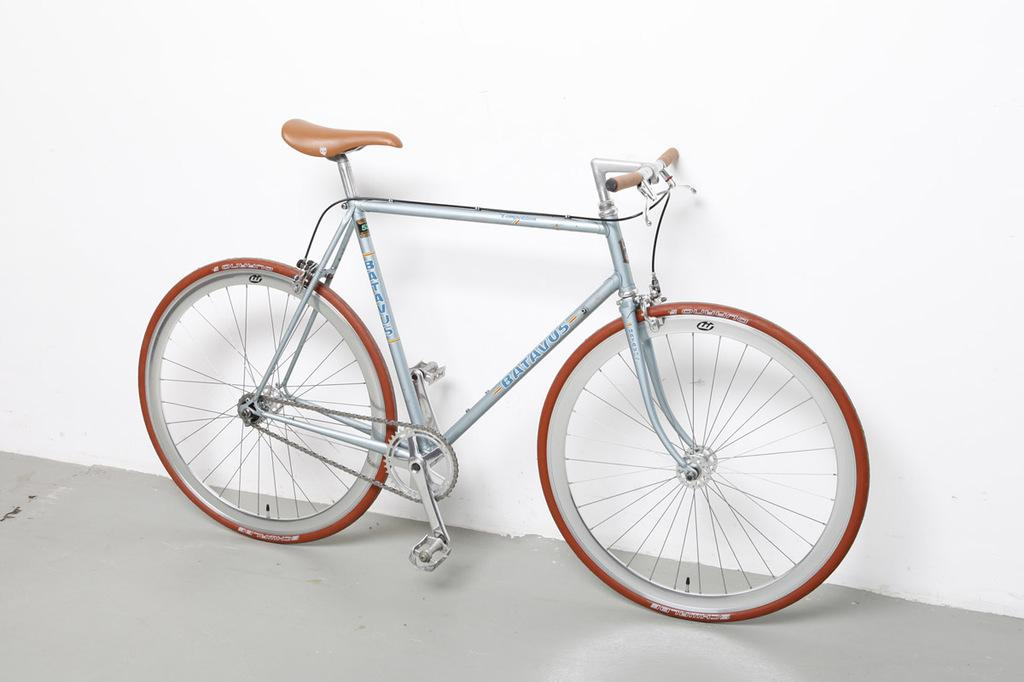What object is on the ground in the image? There is a bicycle on the ground in the image. What can be seen on the wall in the image? There is a white-colored wall in the image. Can you see a cat playing a guitar near the hole in the image? There is no cat, guitar, or hole present in the image. 